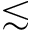Convert formula to latex. <formula><loc_0><loc_0><loc_500><loc_500>\lesssim</formula> 